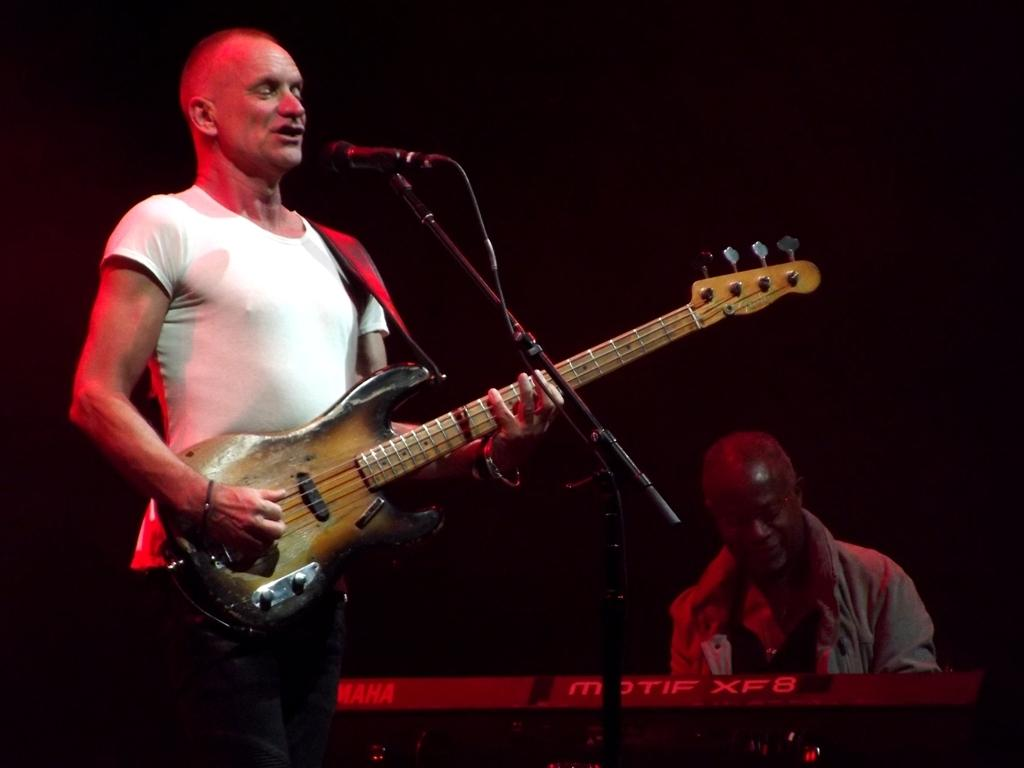How many people are in the image? There are two persons in the image. What is the person on the left holding? The person on the left is holding a guitar. What is the person on the right holding? The person on the right is holding a keyboard. What is in front of the two persons? There is a microphone in front of them. How many toes can be seen on the person on the right? There is no information about the toes of the person on the right in the image, as the focus is on the instruments they are holding and the microphone in front of them. 